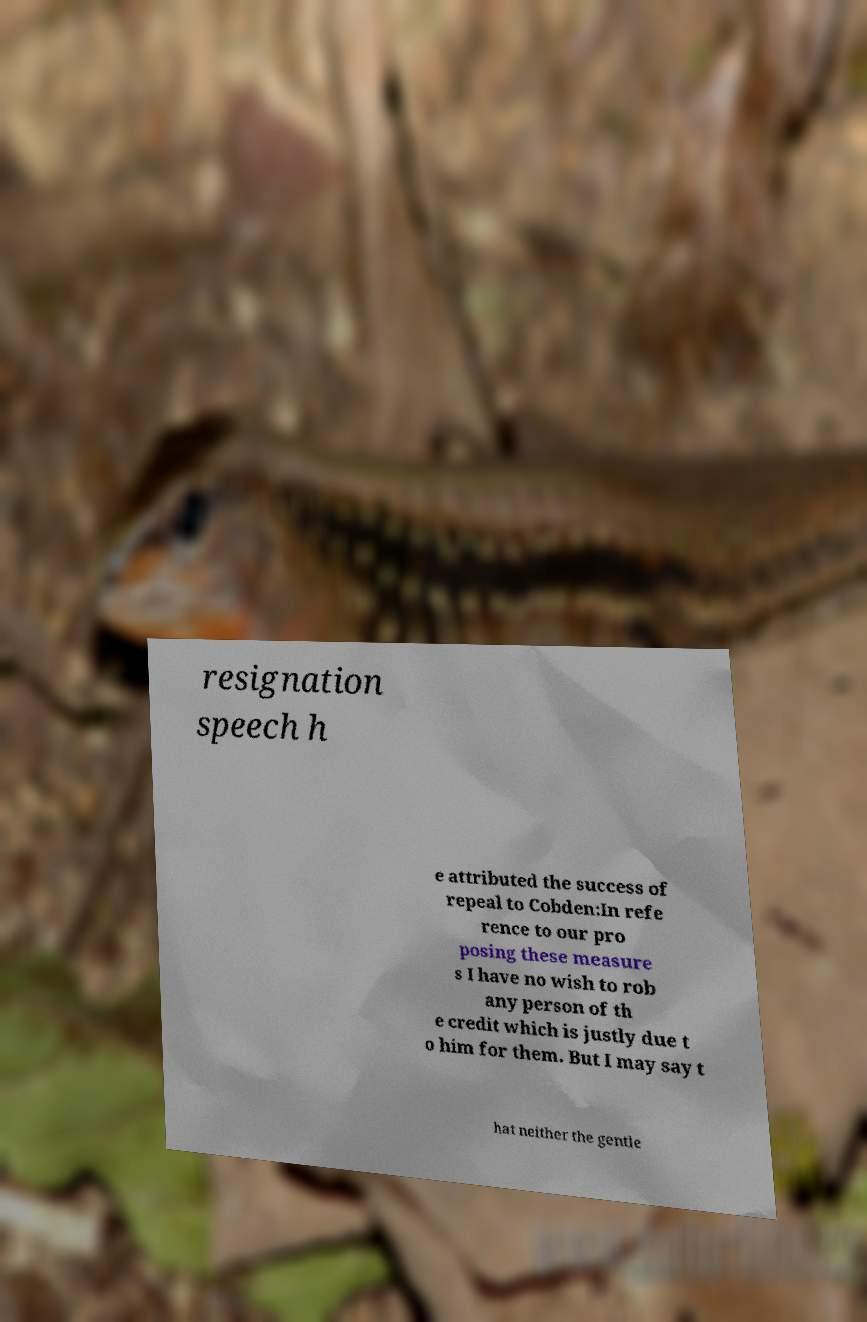Could you extract and type out the text from this image? resignation speech h e attributed the success of repeal to Cobden:In refe rence to our pro posing these measure s I have no wish to rob any person of th e credit which is justly due t o him for them. But I may say t hat neither the gentle 